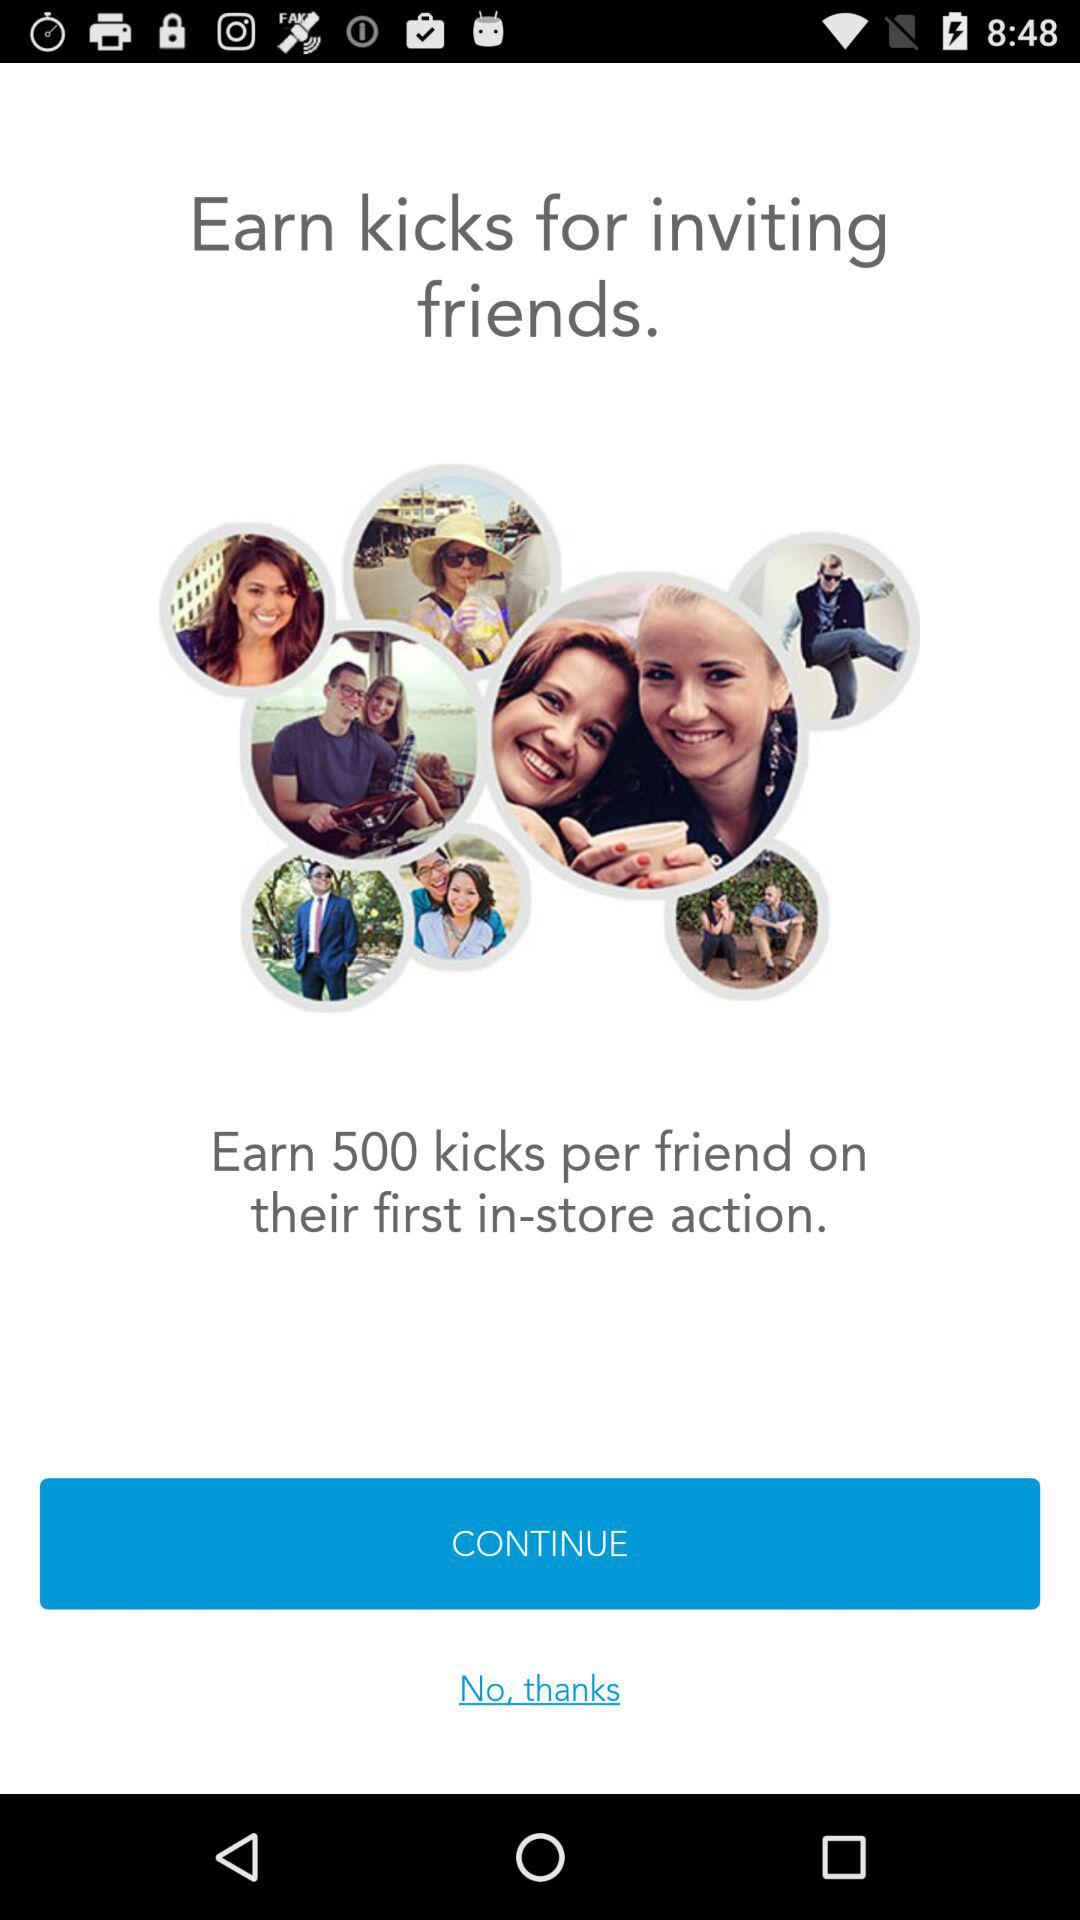How many "kicks" can be earned per friend? You can earn 500 "kicks" per friend. 